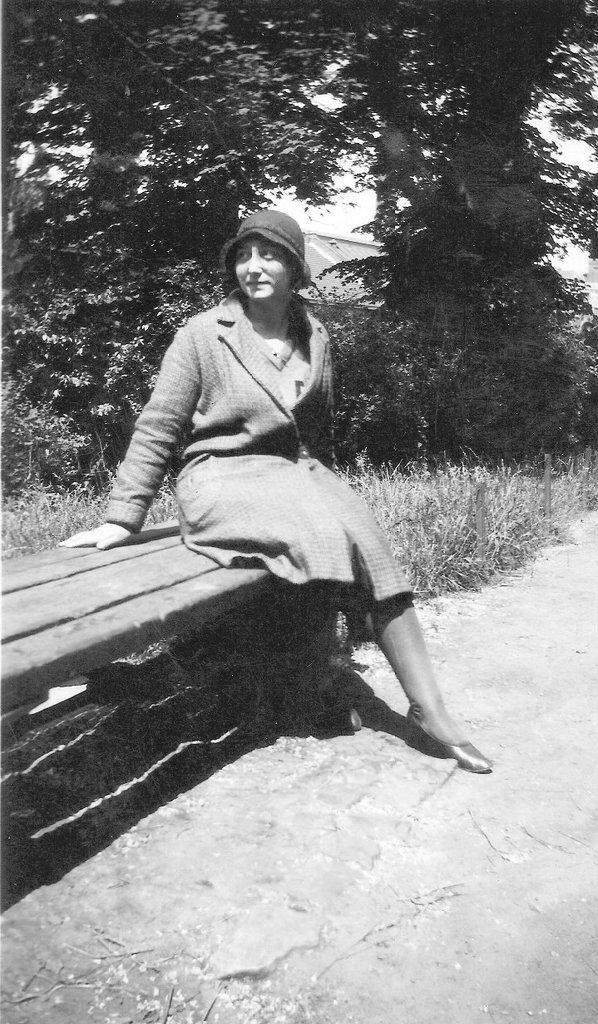Where was the picture taken? The picture was taken outside. What is the main subject in the center of the image? There is a person sitting on a bench in the center of the image. What type of vegetation can be seen in the background of the image? There is grass, plants, and trees in the background of the image. How many kittens are playing on the roof in the image? There are no kittens or roof present in the image. 